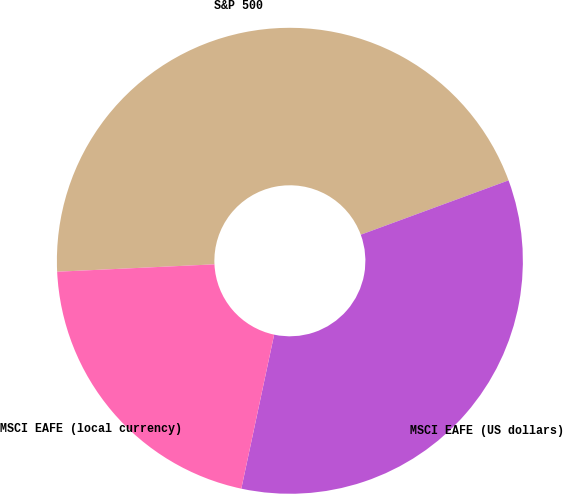Convert chart to OTSL. <chart><loc_0><loc_0><loc_500><loc_500><pie_chart><fcel>S&P 500<fcel>MSCI EAFE (US dollars)<fcel>MSCI EAFE (local currency)<nl><fcel>45.14%<fcel>33.95%<fcel>20.91%<nl></chart> 